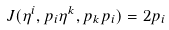Convert formula to latex. <formula><loc_0><loc_0><loc_500><loc_500>J ( \eta ^ { i } , p _ { i } \eta ^ { k } , p _ { k } p _ { i } ) = 2 p _ { i }</formula> 